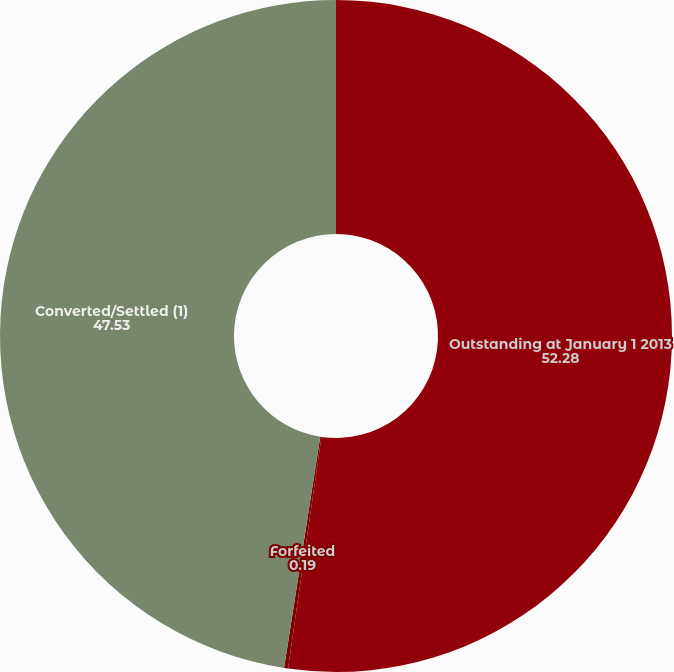Convert chart. <chart><loc_0><loc_0><loc_500><loc_500><pie_chart><fcel>Outstanding at January 1 2013<fcel>Forfeited<fcel>Converted/Settled (1)<nl><fcel>52.28%<fcel>0.19%<fcel>47.53%<nl></chart> 